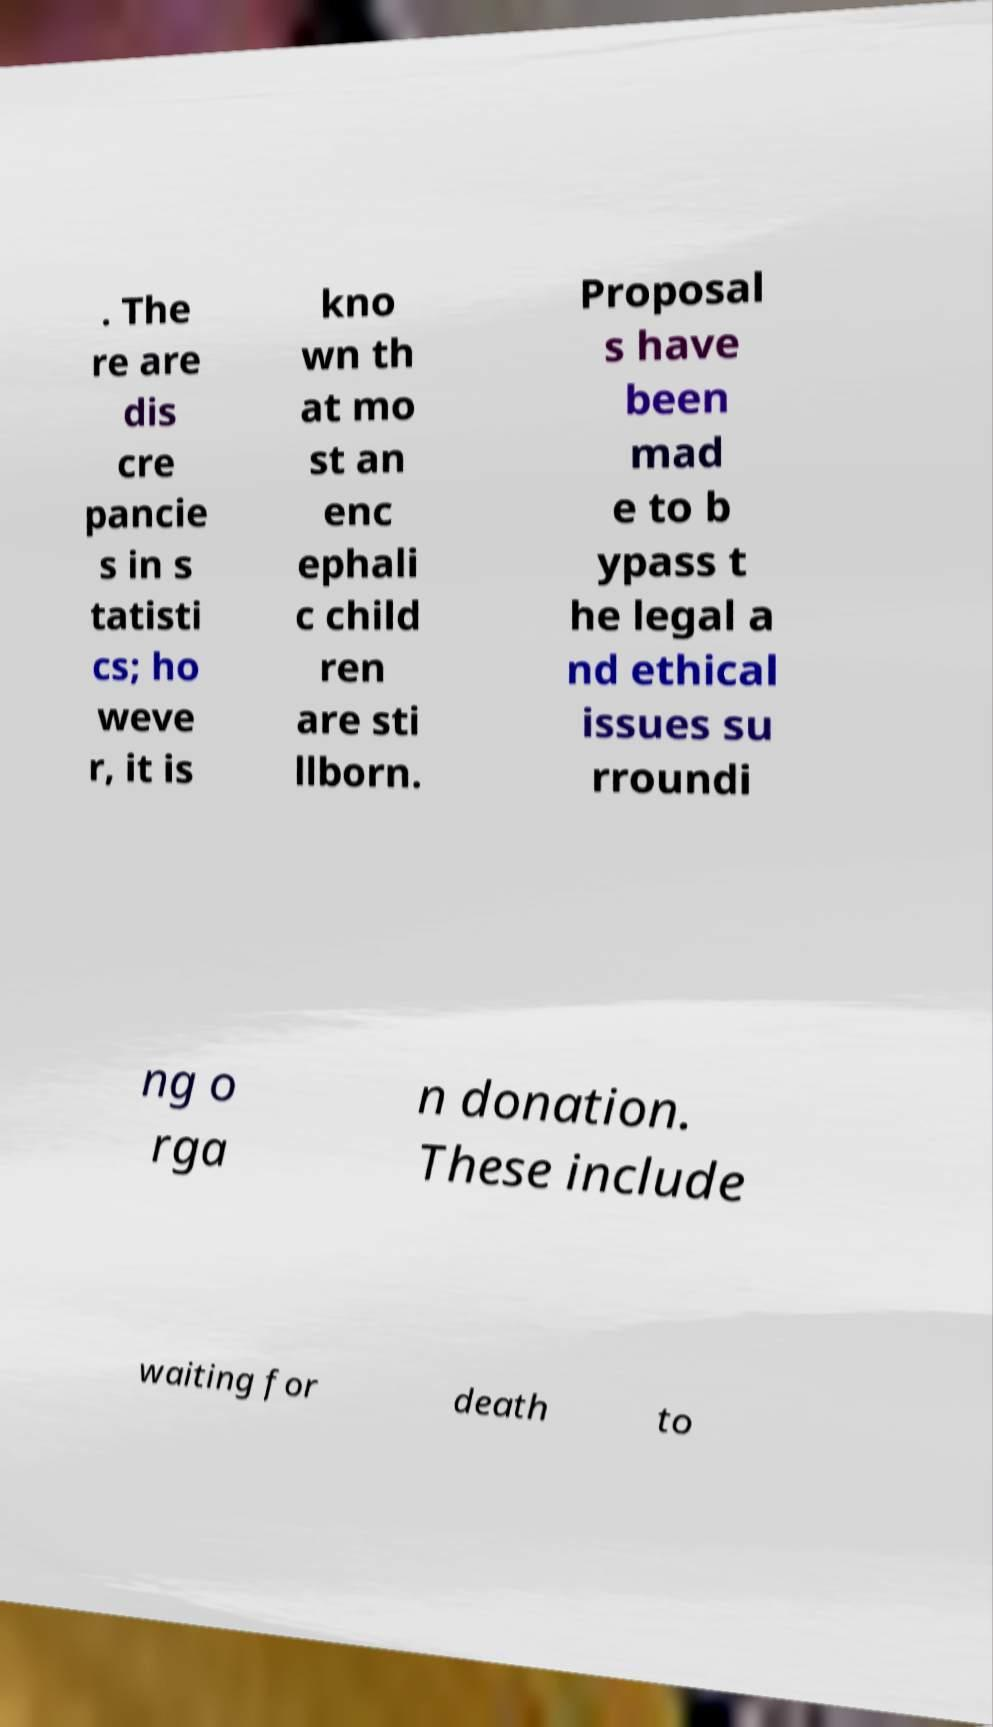For documentation purposes, I need the text within this image transcribed. Could you provide that? . The re are dis cre pancie s in s tatisti cs; ho weve r, it is kno wn th at mo st an enc ephali c child ren are sti llborn. Proposal s have been mad e to b ypass t he legal a nd ethical issues su rroundi ng o rga n donation. These include waiting for death to 